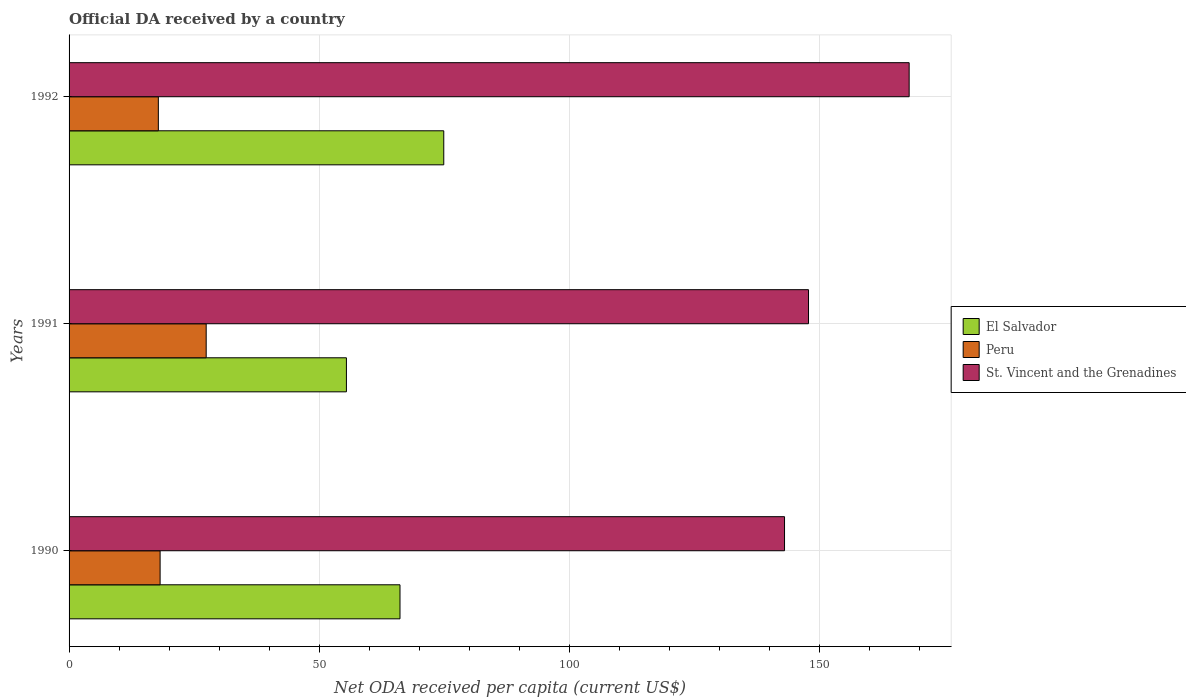How many different coloured bars are there?
Offer a very short reply. 3. How many groups of bars are there?
Your answer should be compact. 3. Are the number of bars on each tick of the Y-axis equal?
Make the answer very short. Yes. How many bars are there on the 1st tick from the top?
Ensure brevity in your answer.  3. What is the label of the 2nd group of bars from the top?
Your response must be concise. 1991. In how many cases, is the number of bars for a given year not equal to the number of legend labels?
Your answer should be compact. 0. What is the ODA received in in El Salvador in 1990?
Offer a very short reply. 66.13. Across all years, what is the maximum ODA received in in Peru?
Give a very brief answer. 27.4. Across all years, what is the minimum ODA received in in Peru?
Provide a succinct answer. 17.84. What is the total ODA received in in Peru in the graph?
Your answer should be compact. 63.43. What is the difference between the ODA received in in El Salvador in 1991 and that in 1992?
Your answer should be very brief. -19.45. What is the difference between the ODA received in in St. Vincent and the Grenadines in 1992 and the ODA received in in Peru in 1991?
Provide a succinct answer. 140.47. What is the average ODA received in in St. Vincent and the Grenadines per year?
Offer a very short reply. 152.86. In the year 1990, what is the difference between the ODA received in in Peru and ODA received in in El Salvador?
Offer a very short reply. -47.93. What is the ratio of the ODA received in in El Salvador in 1990 to that in 1992?
Keep it short and to the point. 0.88. What is the difference between the highest and the second highest ODA received in in Peru?
Make the answer very short. 9.21. What is the difference between the highest and the lowest ODA received in in St. Vincent and the Grenadines?
Keep it short and to the point. 24.9. In how many years, is the ODA received in in El Salvador greater than the average ODA received in in El Salvador taken over all years?
Your answer should be very brief. 2. Is the sum of the ODA received in in El Salvador in 1990 and 1992 greater than the maximum ODA received in in St. Vincent and the Grenadines across all years?
Offer a terse response. No. What does the 1st bar from the top in 1990 represents?
Keep it short and to the point. St. Vincent and the Grenadines. How many bars are there?
Your response must be concise. 9. How many years are there in the graph?
Your answer should be very brief. 3. Does the graph contain grids?
Offer a terse response. Yes. How are the legend labels stacked?
Give a very brief answer. Vertical. What is the title of the graph?
Your response must be concise. Official DA received by a country. What is the label or title of the X-axis?
Ensure brevity in your answer.  Net ODA received per capita (current US$). What is the label or title of the Y-axis?
Ensure brevity in your answer.  Years. What is the Net ODA received per capita (current US$) in El Salvador in 1990?
Provide a short and direct response. 66.13. What is the Net ODA received per capita (current US$) in Peru in 1990?
Offer a very short reply. 18.19. What is the Net ODA received per capita (current US$) in St. Vincent and the Grenadines in 1990?
Offer a very short reply. 142.96. What is the Net ODA received per capita (current US$) in El Salvador in 1991?
Offer a very short reply. 55.42. What is the Net ODA received per capita (current US$) in Peru in 1991?
Your answer should be compact. 27.4. What is the Net ODA received per capita (current US$) in St. Vincent and the Grenadines in 1991?
Ensure brevity in your answer.  147.76. What is the Net ODA received per capita (current US$) in El Salvador in 1992?
Your answer should be compact. 74.87. What is the Net ODA received per capita (current US$) of Peru in 1992?
Provide a succinct answer. 17.84. What is the Net ODA received per capita (current US$) in St. Vincent and the Grenadines in 1992?
Keep it short and to the point. 167.87. Across all years, what is the maximum Net ODA received per capita (current US$) in El Salvador?
Ensure brevity in your answer.  74.87. Across all years, what is the maximum Net ODA received per capita (current US$) in Peru?
Offer a very short reply. 27.4. Across all years, what is the maximum Net ODA received per capita (current US$) in St. Vincent and the Grenadines?
Keep it short and to the point. 167.87. Across all years, what is the minimum Net ODA received per capita (current US$) in El Salvador?
Ensure brevity in your answer.  55.42. Across all years, what is the minimum Net ODA received per capita (current US$) of Peru?
Your response must be concise. 17.84. Across all years, what is the minimum Net ODA received per capita (current US$) in St. Vincent and the Grenadines?
Your response must be concise. 142.96. What is the total Net ODA received per capita (current US$) of El Salvador in the graph?
Keep it short and to the point. 196.42. What is the total Net ODA received per capita (current US$) in Peru in the graph?
Give a very brief answer. 63.43. What is the total Net ODA received per capita (current US$) in St. Vincent and the Grenadines in the graph?
Your answer should be compact. 458.59. What is the difference between the Net ODA received per capita (current US$) in El Salvador in 1990 and that in 1991?
Offer a terse response. 10.71. What is the difference between the Net ODA received per capita (current US$) in Peru in 1990 and that in 1991?
Provide a succinct answer. -9.21. What is the difference between the Net ODA received per capita (current US$) in St. Vincent and the Grenadines in 1990 and that in 1991?
Provide a succinct answer. -4.79. What is the difference between the Net ODA received per capita (current US$) in El Salvador in 1990 and that in 1992?
Your response must be concise. -8.75. What is the difference between the Net ODA received per capita (current US$) of Peru in 1990 and that in 1992?
Ensure brevity in your answer.  0.35. What is the difference between the Net ODA received per capita (current US$) in St. Vincent and the Grenadines in 1990 and that in 1992?
Offer a very short reply. -24.9. What is the difference between the Net ODA received per capita (current US$) in El Salvador in 1991 and that in 1992?
Offer a very short reply. -19.45. What is the difference between the Net ODA received per capita (current US$) in Peru in 1991 and that in 1992?
Make the answer very short. 9.56. What is the difference between the Net ODA received per capita (current US$) in St. Vincent and the Grenadines in 1991 and that in 1992?
Make the answer very short. -20.11. What is the difference between the Net ODA received per capita (current US$) of El Salvador in 1990 and the Net ODA received per capita (current US$) of Peru in 1991?
Your response must be concise. 38.73. What is the difference between the Net ODA received per capita (current US$) in El Salvador in 1990 and the Net ODA received per capita (current US$) in St. Vincent and the Grenadines in 1991?
Make the answer very short. -81.63. What is the difference between the Net ODA received per capita (current US$) of Peru in 1990 and the Net ODA received per capita (current US$) of St. Vincent and the Grenadines in 1991?
Offer a very short reply. -129.57. What is the difference between the Net ODA received per capita (current US$) in El Salvador in 1990 and the Net ODA received per capita (current US$) in Peru in 1992?
Offer a very short reply. 48.29. What is the difference between the Net ODA received per capita (current US$) of El Salvador in 1990 and the Net ODA received per capita (current US$) of St. Vincent and the Grenadines in 1992?
Your response must be concise. -101.74. What is the difference between the Net ODA received per capita (current US$) in Peru in 1990 and the Net ODA received per capita (current US$) in St. Vincent and the Grenadines in 1992?
Your answer should be very brief. -149.68. What is the difference between the Net ODA received per capita (current US$) of El Salvador in 1991 and the Net ODA received per capita (current US$) of Peru in 1992?
Your response must be concise. 37.58. What is the difference between the Net ODA received per capita (current US$) in El Salvador in 1991 and the Net ODA received per capita (current US$) in St. Vincent and the Grenadines in 1992?
Provide a succinct answer. -112.45. What is the difference between the Net ODA received per capita (current US$) of Peru in 1991 and the Net ODA received per capita (current US$) of St. Vincent and the Grenadines in 1992?
Make the answer very short. -140.47. What is the average Net ODA received per capita (current US$) in El Salvador per year?
Offer a terse response. 65.47. What is the average Net ODA received per capita (current US$) in Peru per year?
Your response must be concise. 21.14. What is the average Net ODA received per capita (current US$) in St. Vincent and the Grenadines per year?
Provide a succinct answer. 152.86. In the year 1990, what is the difference between the Net ODA received per capita (current US$) of El Salvador and Net ODA received per capita (current US$) of Peru?
Offer a terse response. 47.93. In the year 1990, what is the difference between the Net ODA received per capita (current US$) in El Salvador and Net ODA received per capita (current US$) in St. Vincent and the Grenadines?
Make the answer very short. -76.84. In the year 1990, what is the difference between the Net ODA received per capita (current US$) of Peru and Net ODA received per capita (current US$) of St. Vincent and the Grenadines?
Make the answer very short. -124.77. In the year 1991, what is the difference between the Net ODA received per capita (current US$) in El Salvador and Net ODA received per capita (current US$) in Peru?
Ensure brevity in your answer.  28.02. In the year 1991, what is the difference between the Net ODA received per capita (current US$) in El Salvador and Net ODA received per capita (current US$) in St. Vincent and the Grenadines?
Ensure brevity in your answer.  -92.34. In the year 1991, what is the difference between the Net ODA received per capita (current US$) in Peru and Net ODA received per capita (current US$) in St. Vincent and the Grenadines?
Offer a terse response. -120.36. In the year 1992, what is the difference between the Net ODA received per capita (current US$) in El Salvador and Net ODA received per capita (current US$) in Peru?
Keep it short and to the point. 57.03. In the year 1992, what is the difference between the Net ODA received per capita (current US$) of El Salvador and Net ODA received per capita (current US$) of St. Vincent and the Grenadines?
Provide a short and direct response. -93. In the year 1992, what is the difference between the Net ODA received per capita (current US$) of Peru and Net ODA received per capita (current US$) of St. Vincent and the Grenadines?
Provide a short and direct response. -150.03. What is the ratio of the Net ODA received per capita (current US$) in El Salvador in 1990 to that in 1991?
Provide a short and direct response. 1.19. What is the ratio of the Net ODA received per capita (current US$) of Peru in 1990 to that in 1991?
Offer a very short reply. 0.66. What is the ratio of the Net ODA received per capita (current US$) in St. Vincent and the Grenadines in 1990 to that in 1991?
Provide a short and direct response. 0.97. What is the ratio of the Net ODA received per capita (current US$) in El Salvador in 1990 to that in 1992?
Keep it short and to the point. 0.88. What is the ratio of the Net ODA received per capita (current US$) in Peru in 1990 to that in 1992?
Keep it short and to the point. 1.02. What is the ratio of the Net ODA received per capita (current US$) of St. Vincent and the Grenadines in 1990 to that in 1992?
Keep it short and to the point. 0.85. What is the ratio of the Net ODA received per capita (current US$) of El Salvador in 1991 to that in 1992?
Your response must be concise. 0.74. What is the ratio of the Net ODA received per capita (current US$) in Peru in 1991 to that in 1992?
Keep it short and to the point. 1.54. What is the ratio of the Net ODA received per capita (current US$) in St. Vincent and the Grenadines in 1991 to that in 1992?
Offer a very short reply. 0.88. What is the difference between the highest and the second highest Net ODA received per capita (current US$) of El Salvador?
Offer a very short reply. 8.75. What is the difference between the highest and the second highest Net ODA received per capita (current US$) in Peru?
Keep it short and to the point. 9.21. What is the difference between the highest and the second highest Net ODA received per capita (current US$) in St. Vincent and the Grenadines?
Offer a terse response. 20.11. What is the difference between the highest and the lowest Net ODA received per capita (current US$) in El Salvador?
Your response must be concise. 19.45. What is the difference between the highest and the lowest Net ODA received per capita (current US$) in Peru?
Your response must be concise. 9.56. What is the difference between the highest and the lowest Net ODA received per capita (current US$) in St. Vincent and the Grenadines?
Keep it short and to the point. 24.9. 